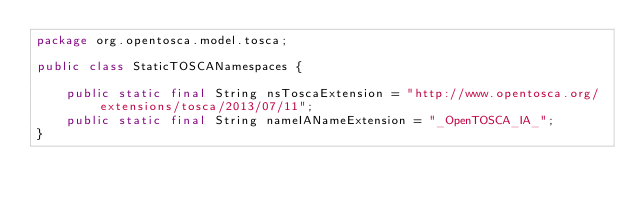<code> <loc_0><loc_0><loc_500><loc_500><_Java_>package org.opentosca.model.tosca;

public class StaticTOSCANamespaces {
	
	public static final String nsToscaExtension = "http://www.opentosca.org/extensions/tosca/2013/07/11";
	public static final String nameIANameExtension = "_OpenTOSCA_IA_";
}
</code> 